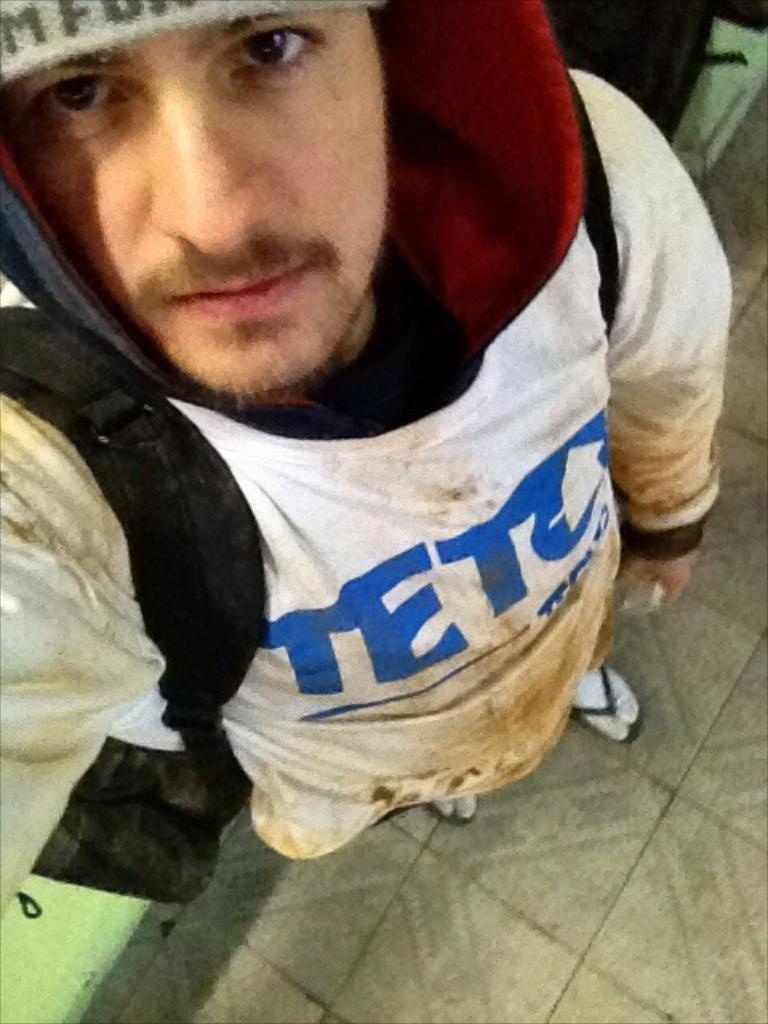<image>
Offer a succinct explanation of the picture presented. A man wearing a dirty white shirt that says Teto on it. 